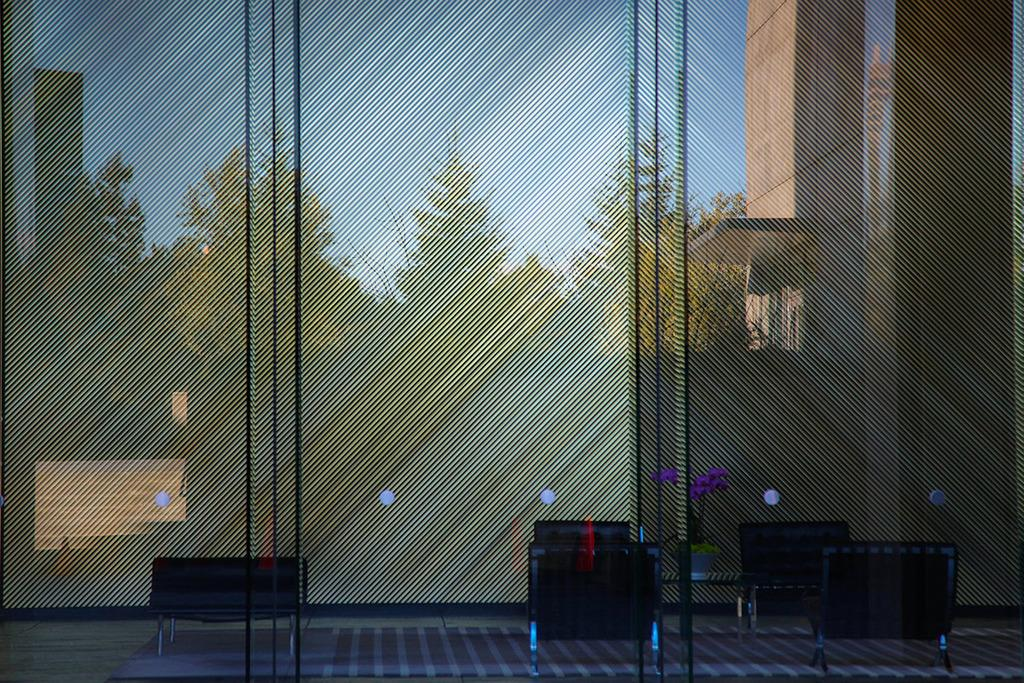What type of furniture is present in the image? There is a table in the image, and chairs are beside the table. What is the material of the wall behind the table? The wall behind the table is made of glass. What can be seen outside the glass wall? Trees and buildings are visible outside the glass wall. What is visible at the top of the image? The sky is visible at the top of the image. What type of feast is being prepared on the table in the image? There is no indication of a feast or any food preparation on the table in the image. How many balls are visible in the image? There are no balls present in the image. 